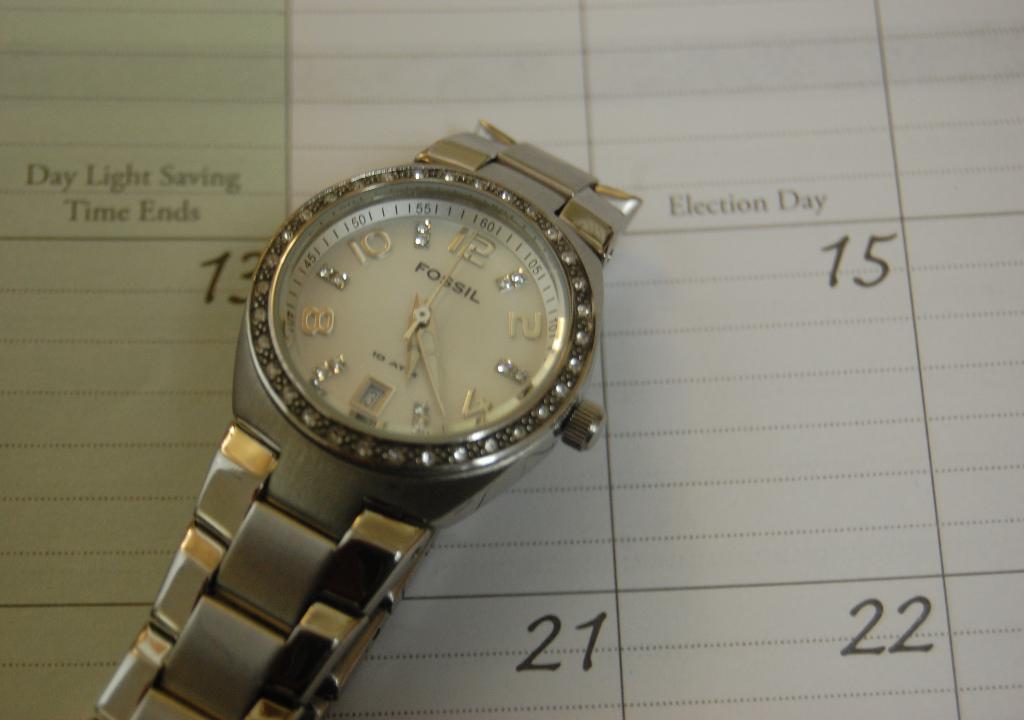What brand of watch is this?
Offer a terse response. Fossil. What is written above 15?
Your response must be concise. Election day. 